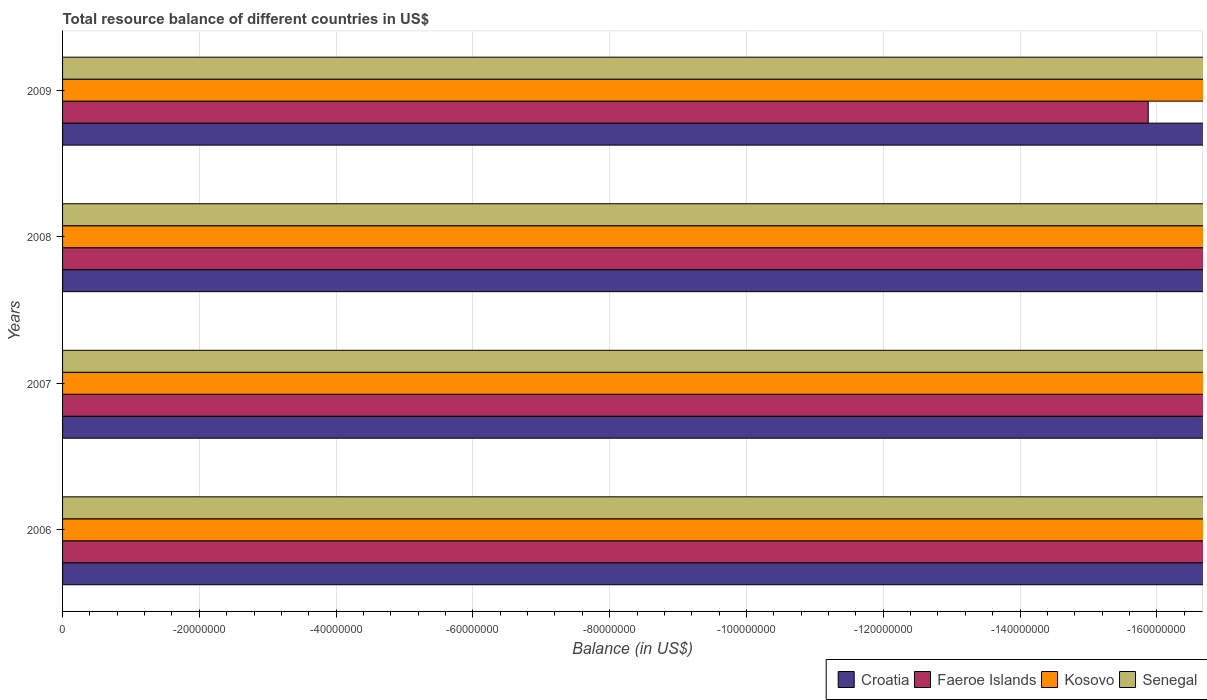Are the number of bars per tick equal to the number of legend labels?
Make the answer very short. No. Are the number of bars on each tick of the Y-axis equal?
Ensure brevity in your answer.  Yes. How many bars are there on the 2nd tick from the bottom?
Provide a succinct answer. 0. In how many cases, is the number of bars for a given year not equal to the number of legend labels?
Offer a terse response. 4. What is the total resource balance in Croatia in 2006?
Your answer should be very brief. 0. What is the average total resource balance in Senegal per year?
Your answer should be very brief. 0. In how many years, is the total resource balance in Senegal greater than -76000000 US$?
Provide a short and direct response. 0. In how many years, is the total resource balance in Faeroe Islands greater than the average total resource balance in Faeroe Islands taken over all years?
Ensure brevity in your answer.  0. Are all the bars in the graph horizontal?
Offer a very short reply. Yes. Does the graph contain any zero values?
Give a very brief answer. Yes. Does the graph contain grids?
Ensure brevity in your answer.  Yes. Where does the legend appear in the graph?
Give a very brief answer. Bottom right. How are the legend labels stacked?
Make the answer very short. Horizontal. What is the title of the graph?
Offer a very short reply. Total resource balance of different countries in US$. What is the label or title of the X-axis?
Your answer should be very brief. Balance (in US$). What is the label or title of the Y-axis?
Give a very brief answer. Years. What is the Balance (in US$) of Croatia in 2006?
Offer a very short reply. 0. What is the Balance (in US$) of Kosovo in 2007?
Make the answer very short. 0. What is the Balance (in US$) of Croatia in 2008?
Offer a terse response. 0. What is the Balance (in US$) in Faeroe Islands in 2008?
Offer a terse response. 0. What is the Balance (in US$) in Senegal in 2008?
Offer a terse response. 0. What is the Balance (in US$) of Faeroe Islands in 2009?
Your response must be concise. 0. What is the total Balance (in US$) of Croatia in the graph?
Make the answer very short. 0. What is the total Balance (in US$) of Faeroe Islands in the graph?
Ensure brevity in your answer.  0. What is the average Balance (in US$) of Kosovo per year?
Ensure brevity in your answer.  0. 